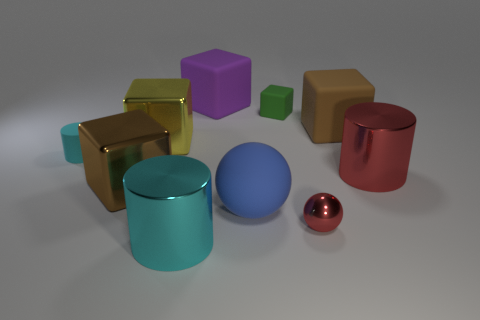What number of other things are the same color as the small matte cube?
Give a very brief answer. 0. How many blue things are matte cubes or blocks?
Provide a succinct answer. 0. What is the brown thing that is in front of the small cyan matte object made of?
Offer a very short reply. Metal. Do the tiny sphere in front of the brown metal cube and the green object have the same material?
Your answer should be very brief. No. The large brown rubber thing is what shape?
Offer a very short reply. Cube. How many cyan shiny cylinders are to the right of the object that is right of the big brown cube behind the yellow object?
Provide a short and direct response. 0. How many other objects are the same material as the large purple cube?
Ensure brevity in your answer.  4. There is a red cylinder that is the same size as the yellow cube; what material is it?
Offer a very short reply. Metal. There is a metal cube that is in front of the large yellow cube; is its color the same as the large block that is to the right of the small green object?
Your answer should be very brief. Yes. Are there any other cyan things of the same shape as the big cyan object?
Make the answer very short. Yes. 